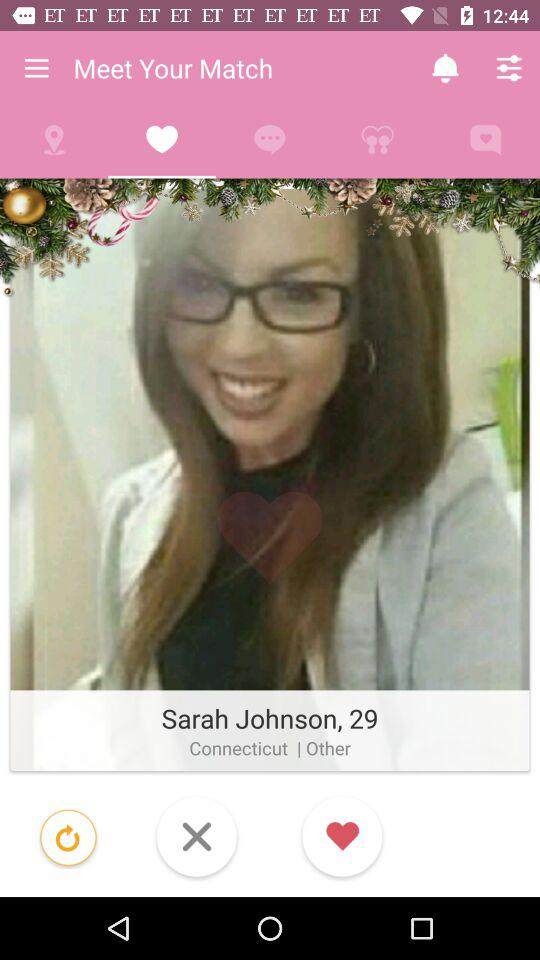What is the age of the person? The age of the person is 29. 